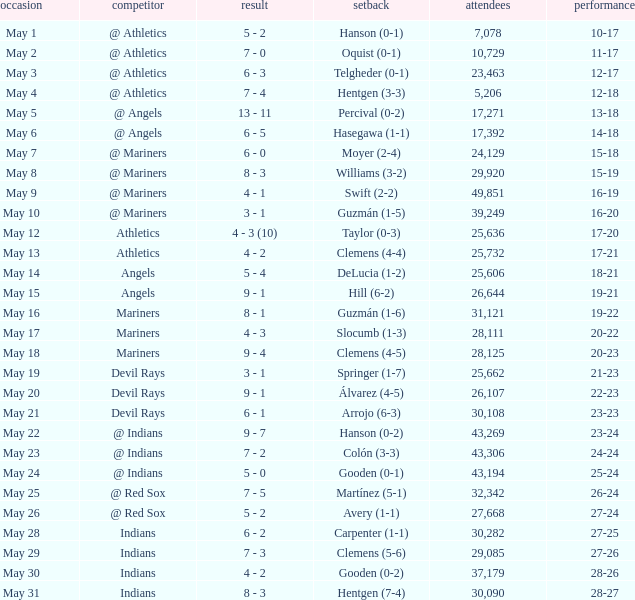When the record is 16-20 and attendance is greater than 32,342, what is the score? 3 - 1. 